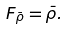<formula> <loc_0><loc_0><loc_500><loc_500>F _ { \bar { \rho } } = \bar { \rho } .</formula> 